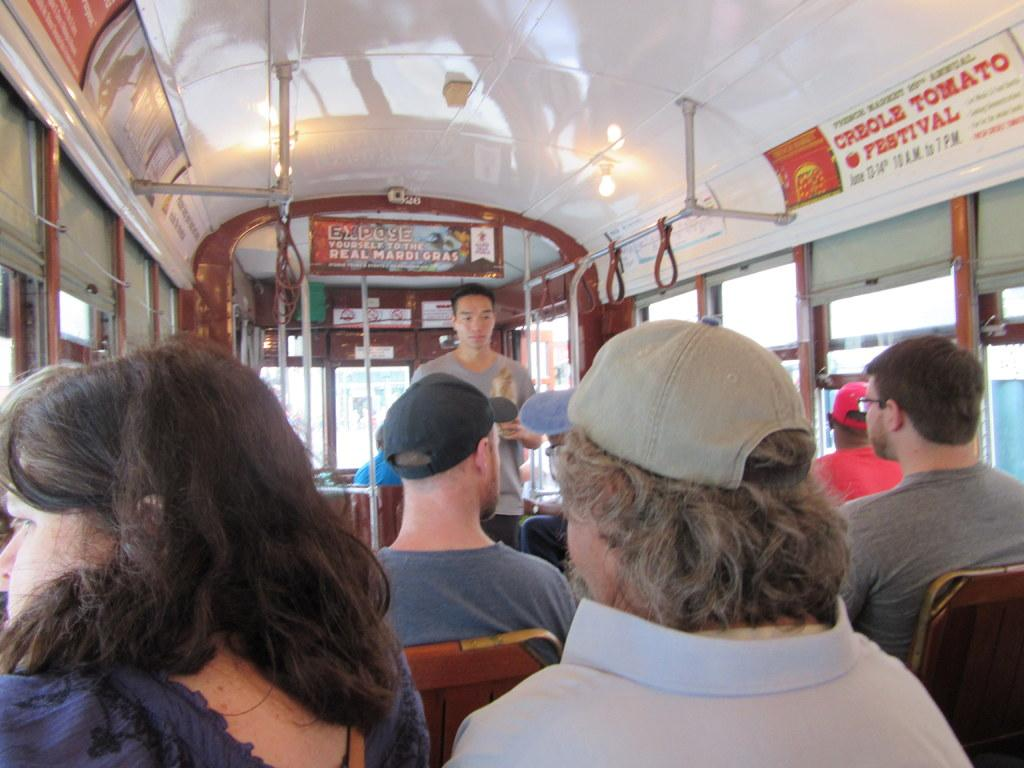What are the people in the image doing? The people in the image are sitting on seats. Is there anyone standing in the image? Yes, there is a person standing in the image. Where are the people located in the image? All the people are inside a vehicle in the image. What type of polish is the person applying to their nails in the image? There is no person applying polish to their nails in the image. Can you see a knife being used by anyone in the image? There is no knife present in the image. 